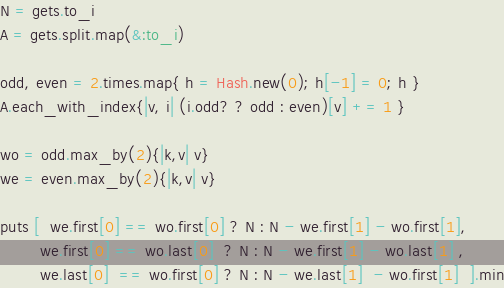<code> <loc_0><loc_0><loc_500><loc_500><_Ruby_>N = gets.to_i
A = gets.split.map(&:to_i)

odd, even = 2.times.map{ h = Hash.new(0); h[-1] = 0; h }
A.each_with_index{|v, i| (i.odd? ? odd : even)[v] += 1 }

wo = odd.max_by(2){|k,v| v}
we = even.max_by(2){|k,v| v}

puts [  we.first[0] == wo.first[0] ? N : N - we.first[1] - wo.first[1], 
        we.first[0] == wo.last[0]  ? N : N - we.first[1] - wo.last[1] ,
        we.last[0]  == wo.first[0] ? N : N - we.last[1]  - wo.first[1]  ].min
</code> 